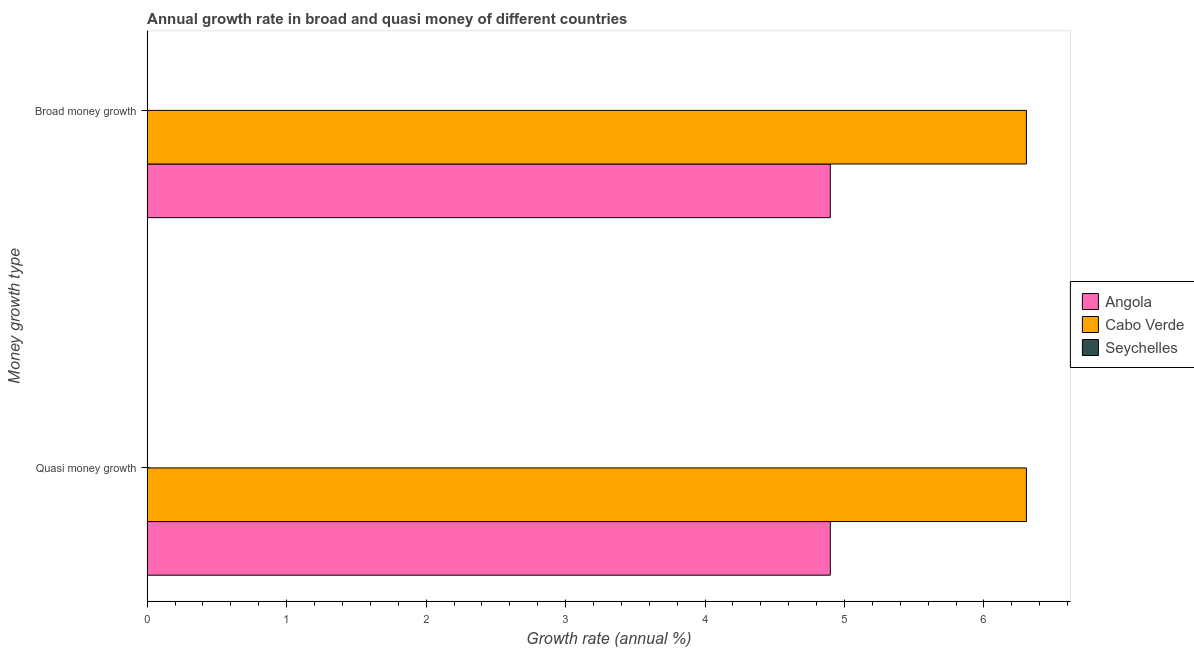How many groups of bars are there?
Offer a terse response. 2. Are the number of bars on each tick of the Y-axis equal?
Provide a short and direct response. Yes. How many bars are there on the 2nd tick from the top?
Ensure brevity in your answer.  2. What is the label of the 1st group of bars from the top?
Provide a short and direct response. Broad money growth. What is the annual growth rate in broad money in Cabo Verde?
Offer a terse response. 6.3. Across all countries, what is the maximum annual growth rate in broad money?
Offer a very short reply. 6.3. In which country was the annual growth rate in quasi money maximum?
Offer a terse response. Cabo Verde. What is the total annual growth rate in broad money in the graph?
Your answer should be very brief. 11.2. What is the difference between the annual growth rate in broad money in Cabo Verde and that in Angola?
Make the answer very short. 1.41. What is the difference between the annual growth rate in quasi money in Seychelles and the annual growth rate in broad money in Angola?
Keep it short and to the point. -4.9. What is the average annual growth rate in broad money per country?
Provide a short and direct response. 3.73. What is the difference between the annual growth rate in broad money and annual growth rate in quasi money in Angola?
Provide a short and direct response. 0. In how many countries, is the annual growth rate in broad money greater than 2.2 %?
Give a very brief answer. 2. What is the ratio of the annual growth rate in broad money in Angola to that in Cabo Verde?
Your response must be concise. 0.78. Is the annual growth rate in broad money in Angola less than that in Cabo Verde?
Provide a succinct answer. Yes. How many bars are there?
Offer a terse response. 4. How many countries are there in the graph?
Your response must be concise. 3. What is the difference between two consecutive major ticks on the X-axis?
Offer a terse response. 1. Are the values on the major ticks of X-axis written in scientific E-notation?
Your answer should be compact. No. Where does the legend appear in the graph?
Provide a succinct answer. Center right. How are the legend labels stacked?
Give a very brief answer. Vertical. What is the title of the graph?
Make the answer very short. Annual growth rate in broad and quasi money of different countries. Does "South Asia" appear as one of the legend labels in the graph?
Keep it short and to the point. No. What is the label or title of the X-axis?
Your answer should be compact. Growth rate (annual %). What is the label or title of the Y-axis?
Your answer should be very brief. Money growth type. What is the Growth rate (annual %) of Angola in Quasi money growth?
Provide a succinct answer. 4.9. What is the Growth rate (annual %) in Cabo Verde in Quasi money growth?
Your response must be concise. 6.3. What is the Growth rate (annual %) in Angola in Broad money growth?
Offer a terse response. 4.9. What is the Growth rate (annual %) of Cabo Verde in Broad money growth?
Offer a very short reply. 6.3. What is the Growth rate (annual %) in Seychelles in Broad money growth?
Your answer should be very brief. 0. Across all Money growth type, what is the maximum Growth rate (annual %) of Angola?
Offer a terse response. 4.9. Across all Money growth type, what is the maximum Growth rate (annual %) of Cabo Verde?
Give a very brief answer. 6.3. Across all Money growth type, what is the minimum Growth rate (annual %) in Angola?
Provide a succinct answer. 4.9. Across all Money growth type, what is the minimum Growth rate (annual %) in Cabo Verde?
Your answer should be compact. 6.3. What is the total Growth rate (annual %) of Angola in the graph?
Ensure brevity in your answer.  9.8. What is the total Growth rate (annual %) of Cabo Verde in the graph?
Keep it short and to the point. 12.61. What is the total Growth rate (annual %) of Seychelles in the graph?
Your answer should be very brief. 0. What is the difference between the Growth rate (annual %) of Cabo Verde in Quasi money growth and that in Broad money growth?
Your answer should be compact. 0. What is the difference between the Growth rate (annual %) in Angola in Quasi money growth and the Growth rate (annual %) in Cabo Verde in Broad money growth?
Your answer should be compact. -1.41. What is the average Growth rate (annual %) of Angola per Money growth type?
Your response must be concise. 4.9. What is the average Growth rate (annual %) in Cabo Verde per Money growth type?
Provide a succinct answer. 6.3. What is the difference between the Growth rate (annual %) of Angola and Growth rate (annual %) of Cabo Verde in Quasi money growth?
Your answer should be compact. -1.41. What is the difference between the Growth rate (annual %) of Angola and Growth rate (annual %) of Cabo Verde in Broad money growth?
Offer a terse response. -1.41. What is the ratio of the Growth rate (annual %) in Cabo Verde in Quasi money growth to that in Broad money growth?
Offer a very short reply. 1. What is the difference between the highest and the second highest Growth rate (annual %) in Angola?
Make the answer very short. 0. What is the difference between the highest and the lowest Growth rate (annual %) in Cabo Verde?
Keep it short and to the point. 0. 